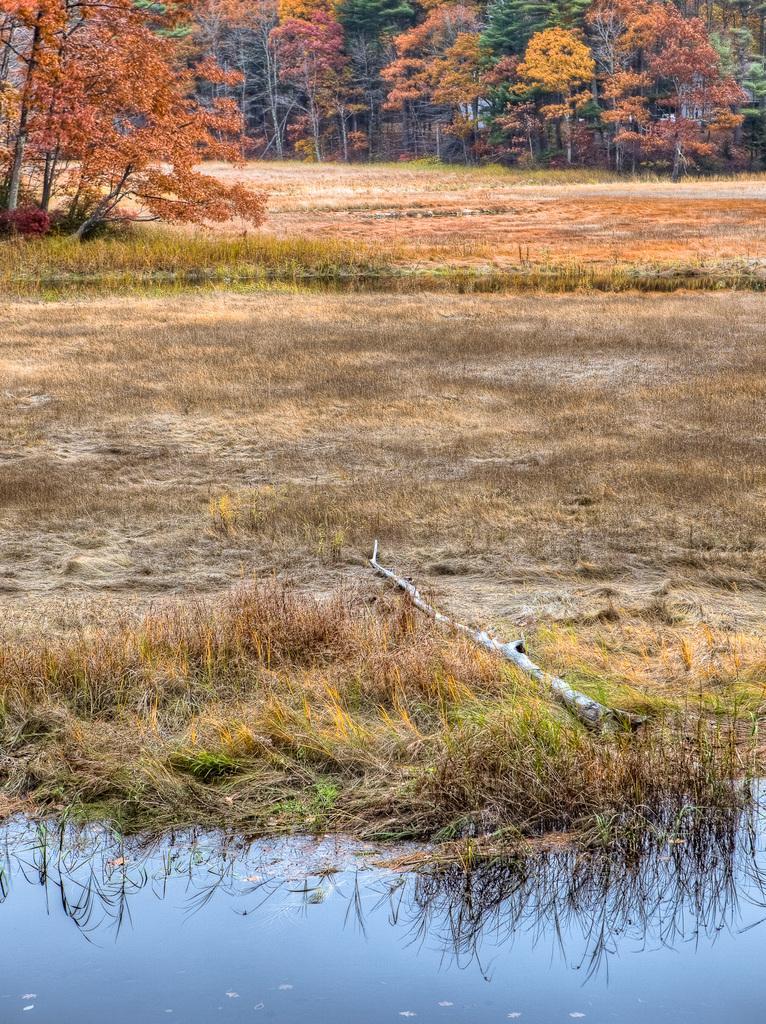Describe this image in one or two sentences. At the bottom of the image there is water. In the background of the image there are trees, dry grass. In the foreground of the image there is a tree bark. 